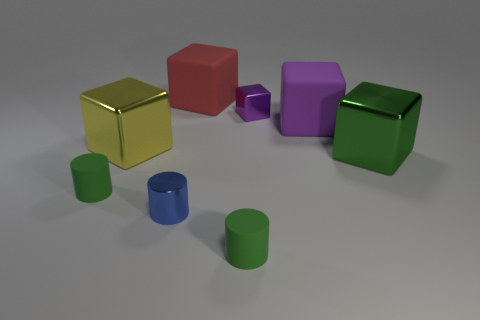Subtract all brown cylinders. Subtract all green balls. How many cylinders are left? 3 Add 1 big gray cylinders. How many objects exist? 9 Subtract all cylinders. How many objects are left? 5 Subtract 1 green blocks. How many objects are left? 7 Subtract all purple matte cylinders. Subtract all green matte cylinders. How many objects are left? 6 Add 2 small purple metallic blocks. How many small purple metallic blocks are left? 3 Add 7 big brown rubber cylinders. How many big brown rubber cylinders exist? 7 